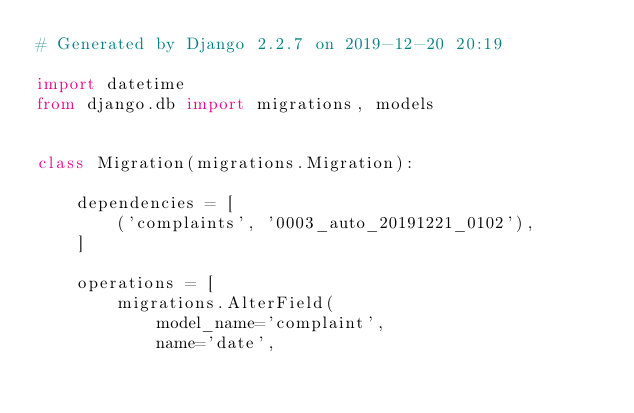Convert code to text. <code><loc_0><loc_0><loc_500><loc_500><_Python_># Generated by Django 2.2.7 on 2019-12-20 20:19

import datetime
from django.db import migrations, models


class Migration(migrations.Migration):

    dependencies = [
        ('complaints', '0003_auto_20191221_0102'),
    ]

    operations = [
        migrations.AlterField(
            model_name='complaint',
            name='date',</code> 